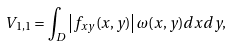Convert formula to latex. <formula><loc_0><loc_0><loc_500><loc_500>V _ { 1 , 1 } = \int _ { D } \left | f _ { x y } ( x , y ) \right | \omega ( x , y ) d x d y ,</formula> 